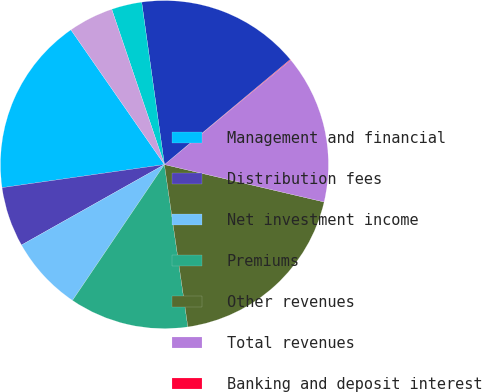Convert chart. <chart><loc_0><loc_0><loc_500><loc_500><pie_chart><fcel>Management and financial<fcel>Distribution fees<fcel>Net investment income<fcel>Premiums<fcel>Other revenues<fcel>Total revenues<fcel>Banking and deposit interest<fcel>Total net revenues<fcel>Distribution expenses<fcel>Interest credited to fixed<nl><fcel>17.59%<fcel>5.91%<fcel>7.37%<fcel>11.75%<fcel>19.05%<fcel>14.67%<fcel>0.07%<fcel>16.13%<fcel>2.99%<fcel>4.45%<nl></chart> 